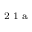Convert formula to latex. <formula><loc_0><loc_0><loc_500><loc_500>^ { 2 } 1 a</formula> 